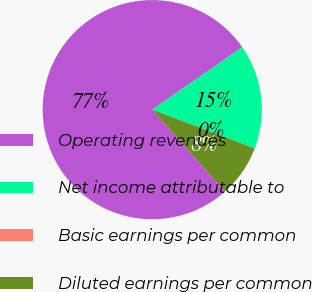Convert chart. <chart><loc_0><loc_0><loc_500><loc_500><pie_chart><fcel>Operating revenues<fcel>Net income attributable to<fcel>Basic earnings per common<fcel>Diluted earnings per common<nl><fcel>76.9%<fcel>15.39%<fcel>0.01%<fcel>7.7%<nl></chart> 